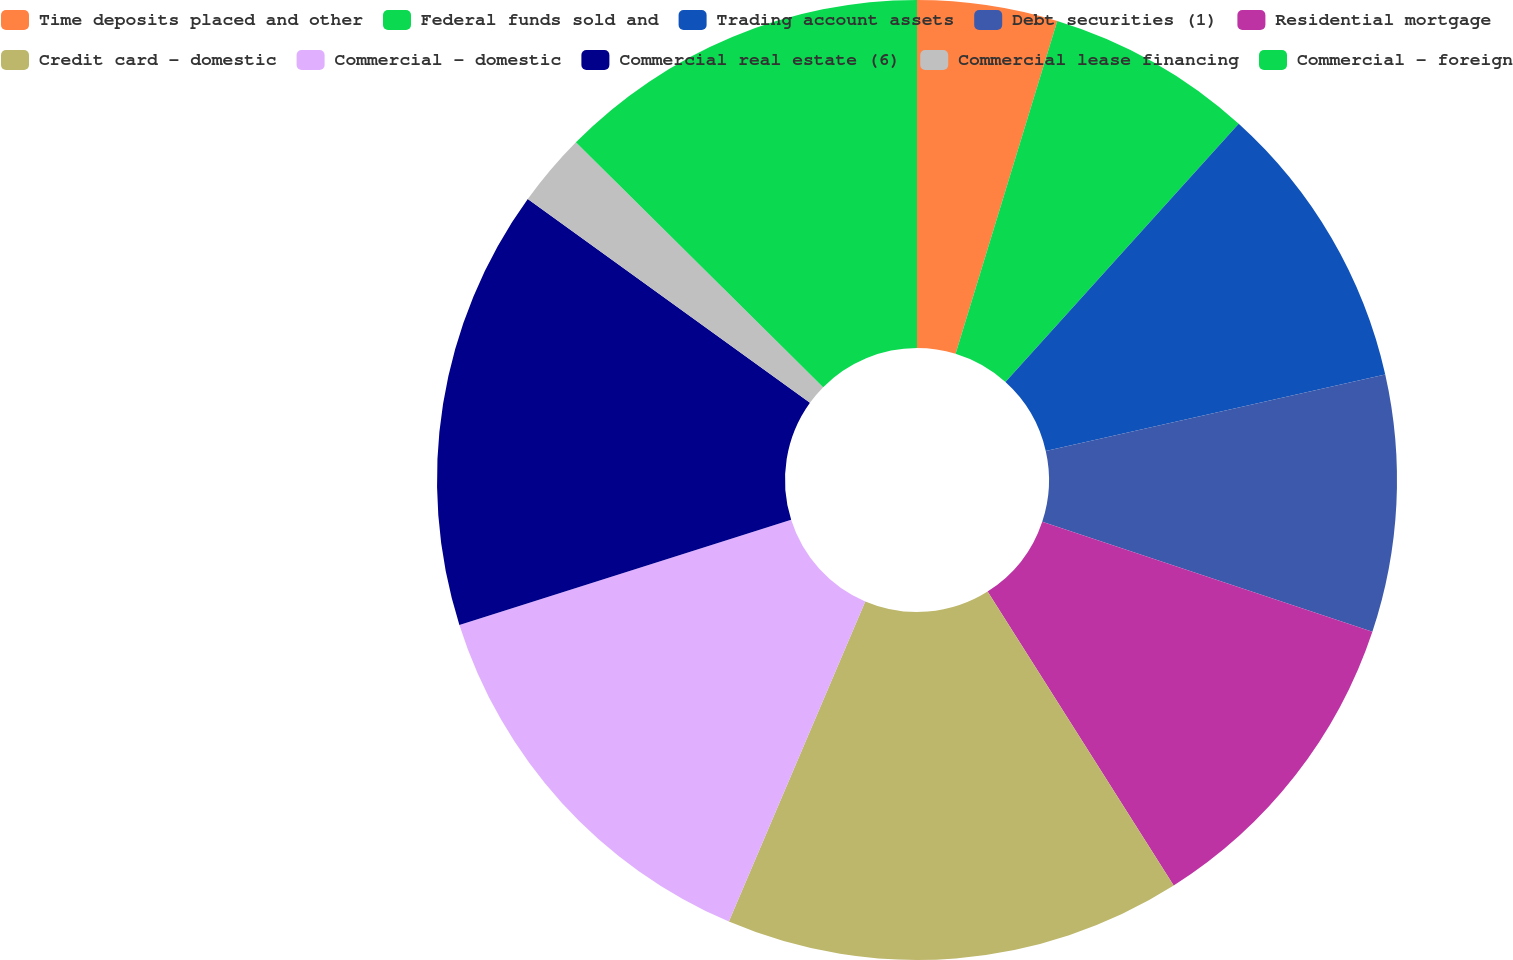Convert chart to OTSL. <chart><loc_0><loc_0><loc_500><loc_500><pie_chart><fcel>Time deposits placed and other<fcel>Federal funds sold and<fcel>Trading account assets<fcel>Debt securities (1)<fcel>Residential mortgage<fcel>Credit card - domestic<fcel>Commercial - domestic<fcel>Commercial real estate (6)<fcel>Commercial lease financing<fcel>Commercial - foreign<nl><fcel>4.72%<fcel>6.97%<fcel>9.78%<fcel>8.65%<fcel>10.9%<fcel>15.39%<fcel>13.71%<fcel>14.83%<fcel>2.47%<fcel>12.58%<nl></chart> 